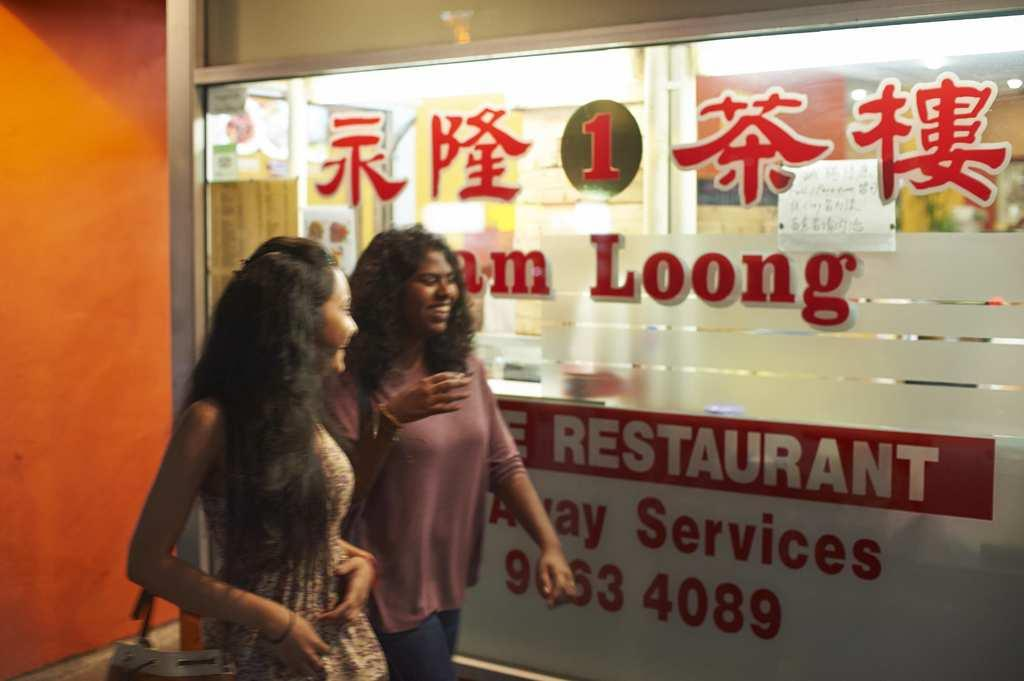What are the two women in the image doing? The two women are walking. Is one of the women carrying anything? Yes, one of the women is holding a bag. What can be seen in the background of the image? There is a glass wall in the image. What is written on the wall? Something is written on the wall. What is on the left side of the image? There is a wall on the left side of the image. What type of whip is being used by the women in the image? There is no whip present in the image; the women are simply walking. How many sticks are visible in the image? There are no sticks visible in the image. 